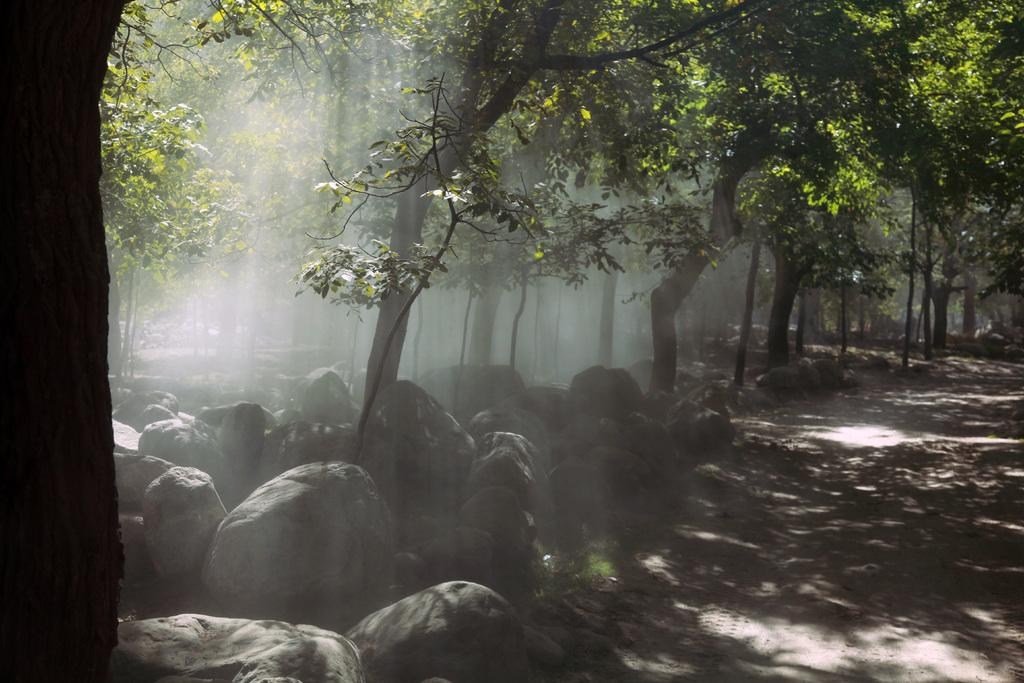What type of natural elements can be seen at the bottom of the image? There are rocks at the bottom side of the image. What type of vegetation is visible in the background of the image? There are trees in the background area of the image. How does the mind pull the rocks in the image? The mind does not pull the rocks in the image; there is no indication of any mental or supernatural force affecting the rocks. 